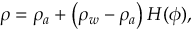Convert formula to latex. <formula><loc_0><loc_0><loc_500><loc_500>\rho = \rho _ { a } + \left ( \rho _ { w } - \rho _ { a } \right ) H ( \phi ) ,</formula> 